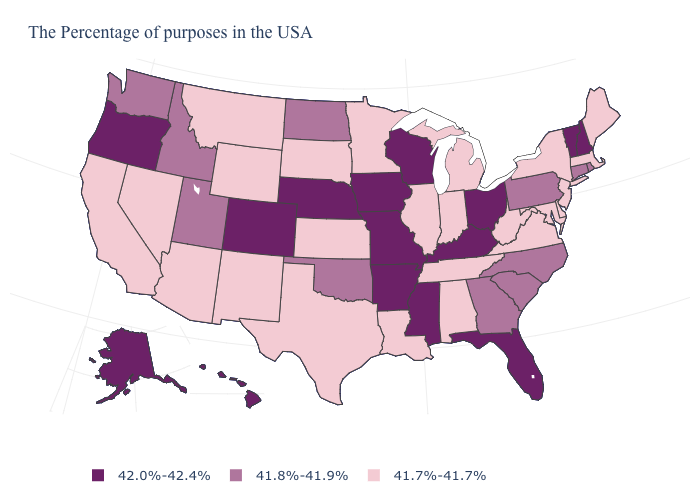Does Oregon have the highest value in the USA?
Write a very short answer. Yes. Does the map have missing data?
Be succinct. No. Which states have the highest value in the USA?
Give a very brief answer. New Hampshire, Vermont, Ohio, Florida, Kentucky, Wisconsin, Mississippi, Missouri, Arkansas, Iowa, Nebraska, Colorado, Oregon, Alaska, Hawaii. Name the states that have a value in the range 41.7%-41.7%?
Write a very short answer. Maine, Massachusetts, New York, New Jersey, Delaware, Maryland, Virginia, West Virginia, Michigan, Indiana, Alabama, Tennessee, Illinois, Louisiana, Minnesota, Kansas, Texas, South Dakota, Wyoming, New Mexico, Montana, Arizona, Nevada, California. What is the value of Maryland?
Quick response, please. 41.7%-41.7%. Does the map have missing data?
Write a very short answer. No. Name the states that have a value in the range 41.7%-41.7%?
Answer briefly. Maine, Massachusetts, New York, New Jersey, Delaware, Maryland, Virginia, West Virginia, Michigan, Indiana, Alabama, Tennessee, Illinois, Louisiana, Minnesota, Kansas, Texas, South Dakota, Wyoming, New Mexico, Montana, Arizona, Nevada, California. What is the value of Delaware?
Keep it brief. 41.7%-41.7%. Name the states that have a value in the range 42.0%-42.4%?
Answer briefly. New Hampshire, Vermont, Ohio, Florida, Kentucky, Wisconsin, Mississippi, Missouri, Arkansas, Iowa, Nebraska, Colorado, Oregon, Alaska, Hawaii. Name the states that have a value in the range 41.8%-41.9%?
Be succinct. Rhode Island, Connecticut, Pennsylvania, North Carolina, South Carolina, Georgia, Oklahoma, North Dakota, Utah, Idaho, Washington. Name the states that have a value in the range 41.8%-41.9%?
Write a very short answer. Rhode Island, Connecticut, Pennsylvania, North Carolina, South Carolina, Georgia, Oklahoma, North Dakota, Utah, Idaho, Washington. What is the lowest value in states that border Florida?
Write a very short answer. 41.7%-41.7%. What is the lowest value in the MidWest?
Quick response, please. 41.7%-41.7%. Which states have the lowest value in the USA?
Answer briefly. Maine, Massachusetts, New York, New Jersey, Delaware, Maryland, Virginia, West Virginia, Michigan, Indiana, Alabama, Tennessee, Illinois, Louisiana, Minnesota, Kansas, Texas, South Dakota, Wyoming, New Mexico, Montana, Arizona, Nevada, California. Name the states that have a value in the range 41.7%-41.7%?
Be succinct. Maine, Massachusetts, New York, New Jersey, Delaware, Maryland, Virginia, West Virginia, Michigan, Indiana, Alabama, Tennessee, Illinois, Louisiana, Minnesota, Kansas, Texas, South Dakota, Wyoming, New Mexico, Montana, Arizona, Nevada, California. 